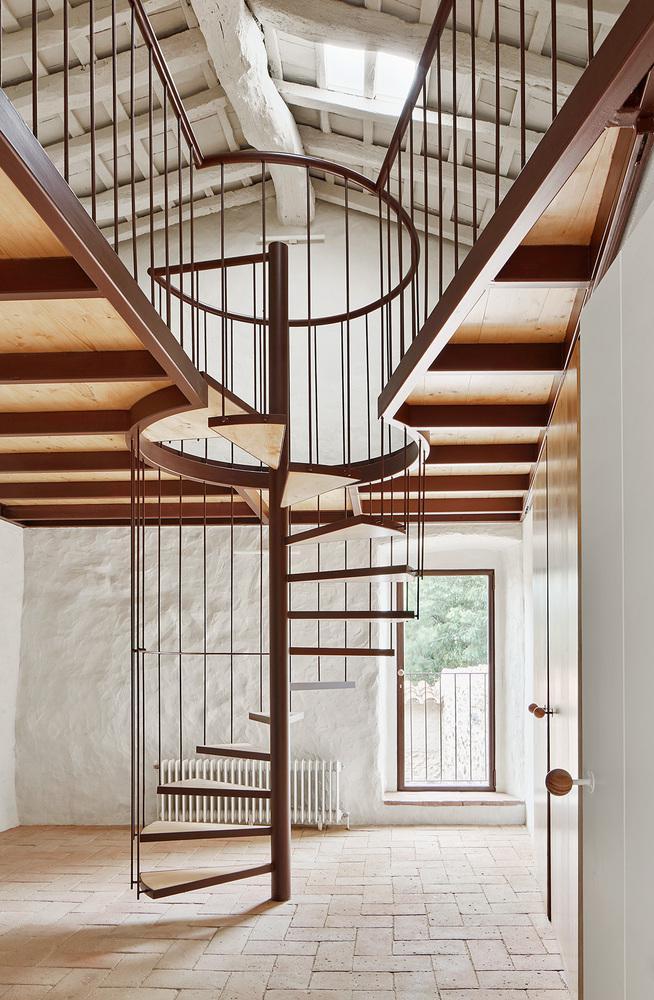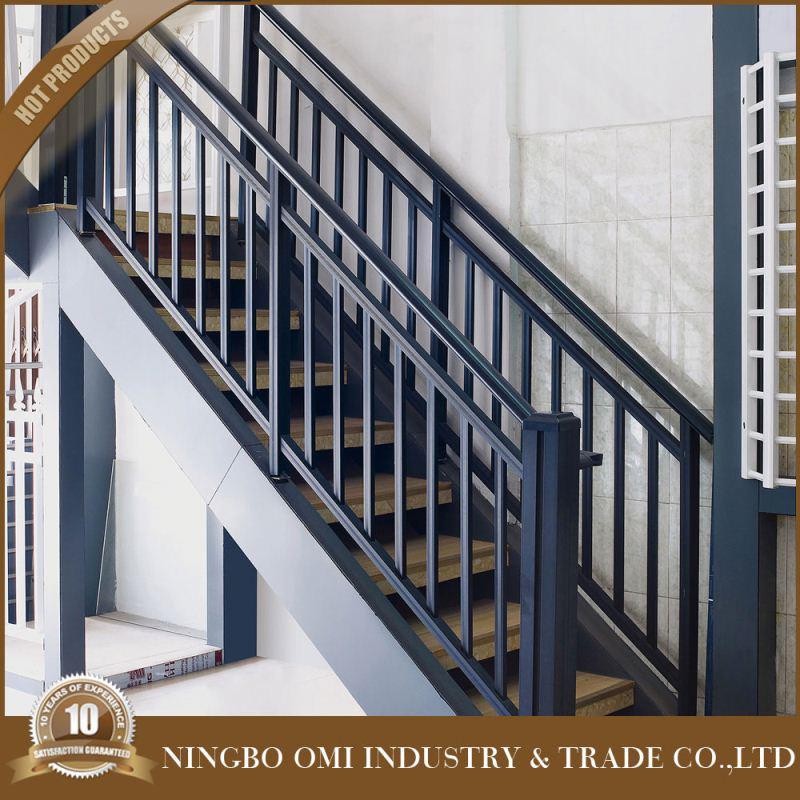The first image is the image on the left, the second image is the image on the right. Evaluate the accuracy of this statement regarding the images: "One image features backless stairs that ascend in a spiral pattern from an upright pole in the center.". Is it true? Answer yes or no. Yes. The first image is the image on the left, the second image is the image on the right. Analyze the images presented: Is the assertion "The staircase in one of the images spirals its way down." valid? Answer yes or no. Yes. 